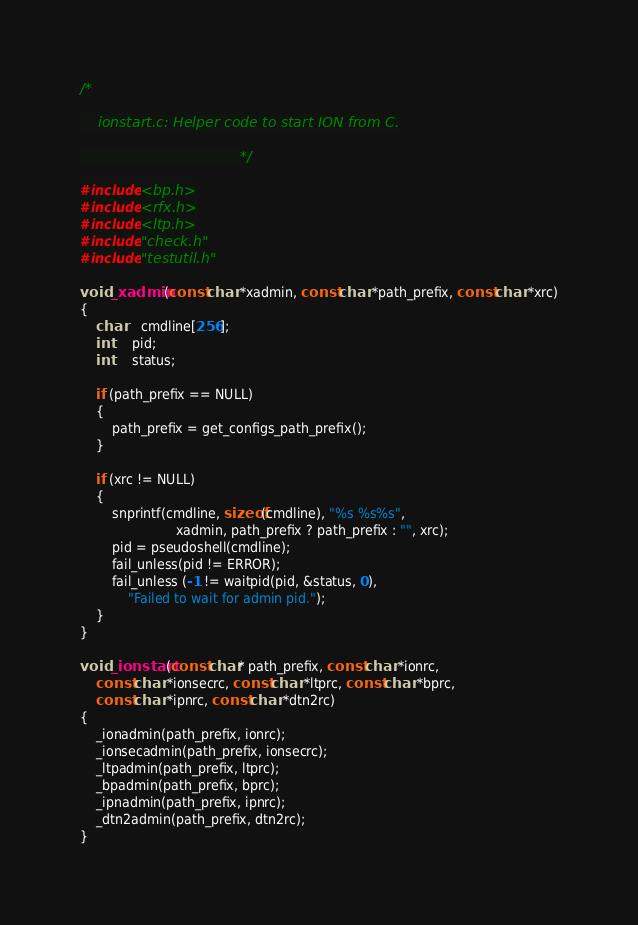<code> <loc_0><loc_0><loc_500><loc_500><_C_>/*

	ionstart.c:	Helper code to start ION from C.

									*/

#include <bp.h>
#include <rfx.h>
#include <ltp.h>
#include "check.h"
#include "testutil.h"

void _xadmin(const char *xadmin, const char *path_prefix, const char *xrc)
{
 	char	cmdline[256];
	int     pid;
	int     status;

    if (path_prefix == NULL)
    {
        path_prefix = get_configs_path_prefix();
    }

 	if (xrc != NULL)
	{
		snprintf(cmdline, sizeof(cmdline), "%s %s%s", 
                        xadmin, path_prefix ? path_prefix : "", xrc);
		pid = pseudoshell(cmdline);
		fail_unless(pid != ERROR);
		fail_unless (-1 != waitpid(pid, &status, 0),
			"Failed to wait for admin pid.");
	}
}

void _ionstart(const char* path_prefix, const char *ionrc, 
    const char *ionsecrc, const char *ltprc, const char *bprc, 
    const char *ipnrc, const char *dtn2rc)
{
    _ionadmin(path_prefix, ionrc);
    _ionsecadmin(path_prefix, ionsecrc);
    _ltpadmin(path_prefix, ltprc);
    _bpadmin(path_prefix, bprc);
    _ipnadmin(path_prefix, ipnrc);
    _dtn2admin(path_prefix, dtn2rc);
}
</code> 